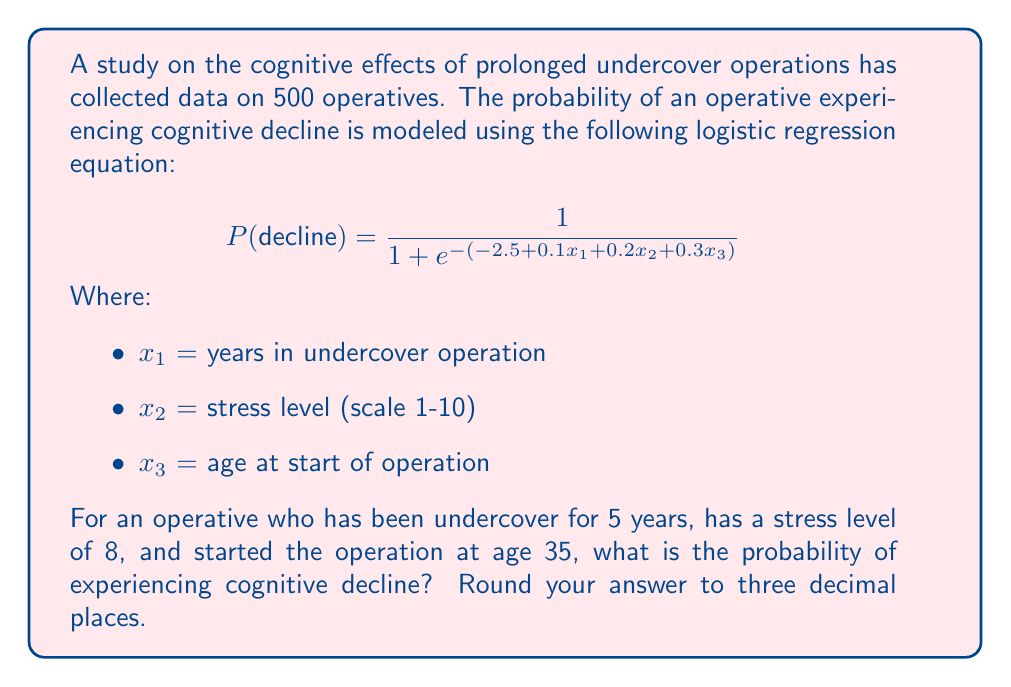Could you help me with this problem? To solve this problem, we need to follow these steps:

1. Identify the values for each variable:
   $x_1 = 5$ (years in undercover operation)
   $x_2 = 8$ (stress level)
   $x_3 = 35$ (age at start of operation)

2. Substitute these values into the logistic regression equation:

   $$ P(decline) = \frac{1}{1 + e^{-(-2.5 + 0.1x_1 + 0.2x_2 + 0.3x_3)}} $$
   $$ P(decline) = \frac{1}{1 + e^{-(-2.5 + 0.1(5) + 0.2(8) + 0.3(35))}} $$

3. Calculate the expression inside the exponential:
   $-2.5 + 0.1(5) + 0.2(8) + 0.3(35) = -2.5 + 0.5 + 1.6 + 10.5 = 10.1$

4. Simplify the equation:
   $$ P(decline) = \frac{1}{1 + e^{-10.1}} $$

5. Calculate $e^{-10.1}$:
   $e^{-10.1} \approx 0.0000411$

6. Substitute this value and calculate the final probability:
   $$ P(decline) = \frac{1}{1 + 0.0000411} \approx 0.9999589 $$

7. Round to three decimal places:
   $P(decline) \approx 1.000$
Answer: $1.000$ 